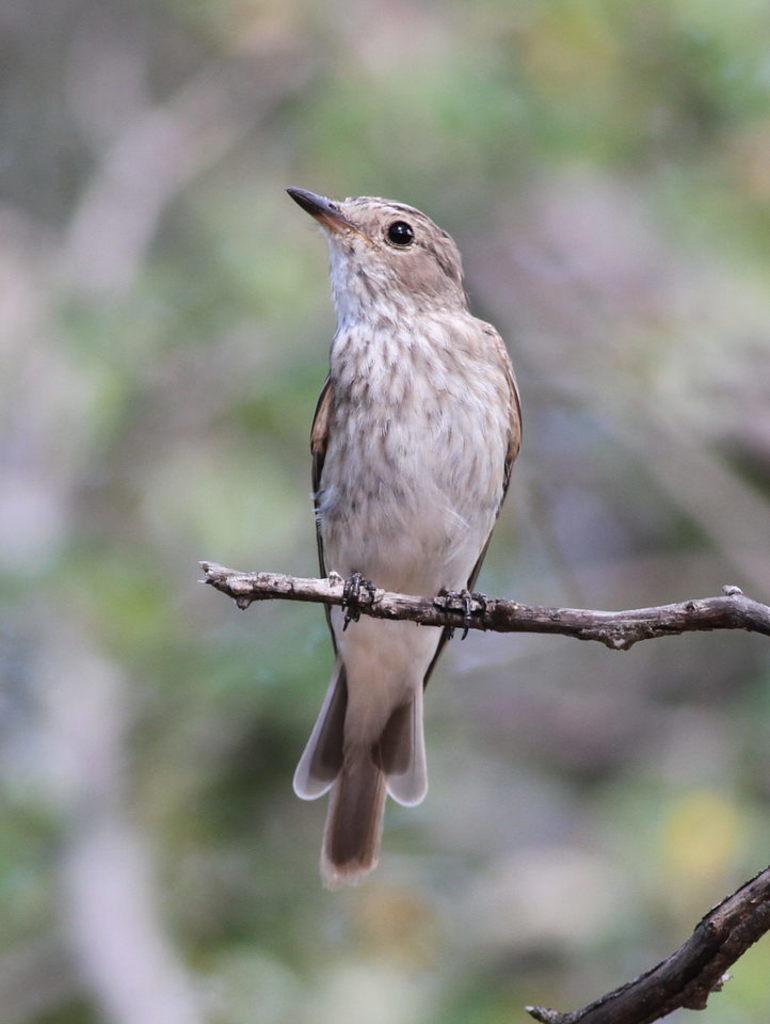In one or two sentences, can you explain what this image depicts? In the image there is a bird sitting on a branch, the background of the bird is blue. 